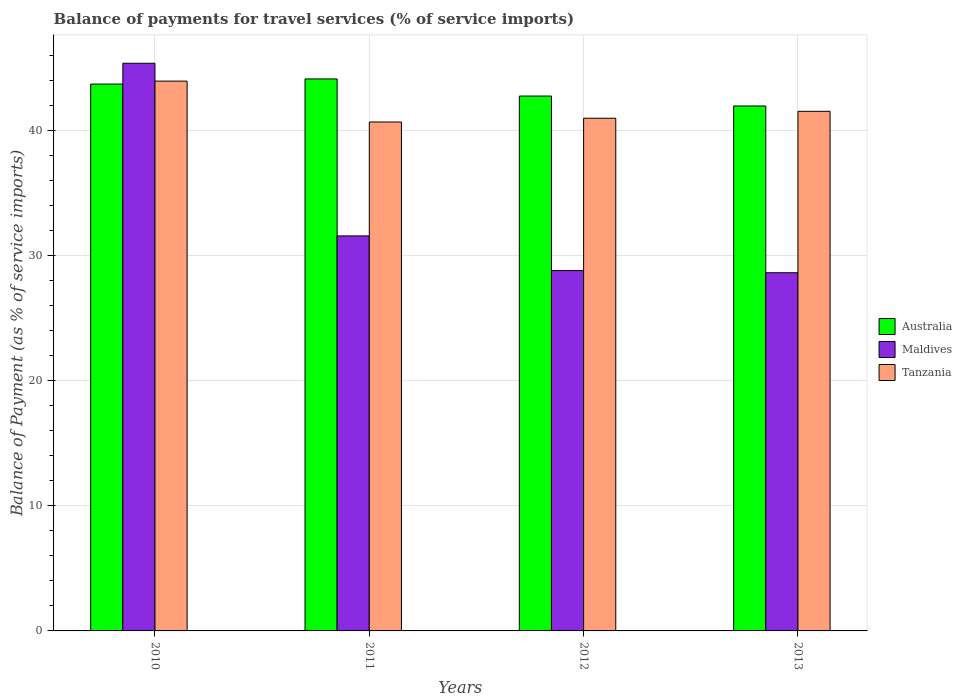How many groups of bars are there?
Keep it short and to the point. 4. Are the number of bars per tick equal to the number of legend labels?
Offer a terse response. Yes. Are the number of bars on each tick of the X-axis equal?
Offer a very short reply. Yes. How many bars are there on the 4th tick from the left?
Make the answer very short. 3. What is the label of the 2nd group of bars from the left?
Your response must be concise. 2011. In how many cases, is the number of bars for a given year not equal to the number of legend labels?
Offer a terse response. 0. What is the balance of payments for travel services in Maldives in 2012?
Keep it short and to the point. 28.81. Across all years, what is the maximum balance of payments for travel services in Maldives?
Provide a succinct answer. 45.39. Across all years, what is the minimum balance of payments for travel services in Tanzania?
Your response must be concise. 40.7. In which year was the balance of payments for travel services in Australia maximum?
Make the answer very short. 2011. What is the total balance of payments for travel services in Maldives in the graph?
Make the answer very short. 134.43. What is the difference between the balance of payments for travel services in Maldives in 2010 and that in 2013?
Your response must be concise. 16.75. What is the difference between the balance of payments for travel services in Tanzania in 2012 and the balance of payments for travel services in Australia in 2013?
Your answer should be compact. -0.98. What is the average balance of payments for travel services in Maldives per year?
Give a very brief answer. 33.61. In the year 2012, what is the difference between the balance of payments for travel services in Tanzania and balance of payments for travel services in Australia?
Provide a short and direct response. -1.77. What is the ratio of the balance of payments for travel services in Australia in 2012 to that in 2013?
Your answer should be compact. 1.02. Is the balance of payments for travel services in Maldives in 2011 less than that in 2012?
Your response must be concise. No. Is the difference between the balance of payments for travel services in Tanzania in 2011 and 2012 greater than the difference between the balance of payments for travel services in Australia in 2011 and 2012?
Provide a succinct answer. No. What is the difference between the highest and the second highest balance of payments for travel services in Maldives?
Provide a succinct answer. 13.81. What is the difference between the highest and the lowest balance of payments for travel services in Australia?
Offer a terse response. 2.16. In how many years, is the balance of payments for travel services in Tanzania greater than the average balance of payments for travel services in Tanzania taken over all years?
Provide a succinct answer. 1. What does the 2nd bar from the right in 2011 represents?
Your response must be concise. Maldives. Is it the case that in every year, the sum of the balance of payments for travel services in Australia and balance of payments for travel services in Maldives is greater than the balance of payments for travel services in Tanzania?
Your answer should be compact. Yes. Does the graph contain grids?
Offer a very short reply. Yes. What is the title of the graph?
Provide a short and direct response. Balance of payments for travel services (% of service imports). Does "Bhutan" appear as one of the legend labels in the graph?
Offer a very short reply. No. What is the label or title of the X-axis?
Give a very brief answer. Years. What is the label or title of the Y-axis?
Give a very brief answer. Balance of Payment (as % of service imports). What is the Balance of Payment (as % of service imports) in Australia in 2010?
Ensure brevity in your answer.  43.73. What is the Balance of Payment (as % of service imports) in Maldives in 2010?
Your response must be concise. 45.39. What is the Balance of Payment (as % of service imports) of Tanzania in 2010?
Offer a very short reply. 43.96. What is the Balance of Payment (as % of service imports) of Australia in 2011?
Your answer should be very brief. 44.14. What is the Balance of Payment (as % of service imports) of Maldives in 2011?
Keep it short and to the point. 31.59. What is the Balance of Payment (as % of service imports) in Tanzania in 2011?
Provide a succinct answer. 40.7. What is the Balance of Payment (as % of service imports) in Australia in 2012?
Make the answer very short. 42.77. What is the Balance of Payment (as % of service imports) of Maldives in 2012?
Offer a very short reply. 28.81. What is the Balance of Payment (as % of service imports) of Tanzania in 2012?
Offer a very short reply. 40.99. What is the Balance of Payment (as % of service imports) in Australia in 2013?
Your answer should be compact. 41.98. What is the Balance of Payment (as % of service imports) in Maldives in 2013?
Make the answer very short. 28.64. What is the Balance of Payment (as % of service imports) in Tanzania in 2013?
Offer a terse response. 41.55. Across all years, what is the maximum Balance of Payment (as % of service imports) in Australia?
Your answer should be compact. 44.14. Across all years, what is the maximum Balance of Payment (as % of service imports) of Maldives?
Offer a terse response. 45.39. Across all years, what is the maximum Balance of Payment (as % of service imports) of Tanzania?
Provide a succinct answer. 43.96. Across all years, what is the minimum Balance of Payment (as % of service imports) in Australia?
Provide a short and direct response. 41.98. Across all years, what is the minimum Balance of Payment (as % of service imports) of Maldives?
Give a very brief answer. 28.64. Across all years, what is the minimum Balance of Payment (as % of service imports) of Tanzania?
Provide a succinct answer. 40.7. What is the total Balance of Payment (as % of service imports) in Australia in the graph?
Offer a terse response. 172.61. What is the total Balance of Payment (as % of service imports) of Maldives in the graph?
Offer a very short reply. 134.43. What is the total Balance of Payment (as % of service imports) of Tanzania in the graph?
Provide a short and direct response. 167.2. What is the difference between the Balance of Payment (as % of service imports) in Australia in 2010 and that in 2011?
Make the answer very short. -0.41. What is the difference between the Balance of Payment (as % of service imports) of Maldives in 2010 and that in 2011?
Your answer should be very brief. 13.81. What is the difference between the Balance of Payment (as % of service imports) of Tanzania in 2010 and that in 2011?
Your answer should be very brief. 3.27. What is the difference between the Balance of Payment (as % of service imports) in Australia in 2010 and that in 2012?
Offer a very short reply. 0.96. What is the difference between the Balance of Payment (as % of service imports) of Maldives in 2010 and that in 2012?
Your answer should be very brief. 16.58. What is the difference between the Balance of Payment (as % of service imports) of Tanzania in 2010 and that in 2012?
Give a very brief answer. 2.97. What is the difference between the Balance of Payment (as % of service imports) in Australia in 2010 and that in 2013?
Offer a very short reply. 1.75. What is the difference between the Balance of Payment (as % of service imports) of Maldives in 2010 and that in 2013?
Your answer should be very brief. 16.75. What is the difference between the Balance of Payment (as % of service imports) in Tanzania in 2010 and that in 2013?
Offer a very short reply. 2.42. What is the difference between the Balance of Payment (as % of service imports) in Australia in 2011 and that in 2012?
Your answer should be very brief. 1.37. What is the difference between the Balance of Payment (as % of service imports) in Maldives in 2011 and that in 2012?
Make the answer very short. 2.77. What is the difference between the Balance of Payment (as % of service imports) of Tanzania in 2011 and that in 2012?
Offer a very short reply. -0.3. What is the difference between the Balance of Payment (as % of service imports) of Australia in 2011 and that in 2013?
Ensure brevity in your answer.  2.16. What is the difference between the Balance of Payment (as % of service imports) of Maldives in 2011 and that in 2013?
Ensure brevity in your answer.  2.94. What is the difference between the Balance of Payment (as % of service imports) in Tanzania in 2011 and that in 2013?
Provide a short and direct response. -0.85. What is the difference between the Balance of Payment (as % of service imports) in Australia in 2012 and that in 2013?
Your answer should be very brief. 0.79. What is the difference between the Balance of Payment (as % of service imports) of Maldives in 2012 and that in 2013?
Your answer should be compact. 0.17. What is the difference between the Balance of Payment (as % of service imports) of Tanzania in 2012 and that in 2013?
Provide a succinct answer. -0.55. What is the difference between the Balance of Payment (as % of service imports) in Australia in 2010 and the Balance of Payment (as % of service imports) in Maldives in 2011?
Provide a short and direct response. 12.14. What is the difference between the Balance of Payment (as % of service imports) of Australia in 2010 and the Balance of Payment (as % of service imports) of Tanzania in 2011?
Your answer should be very brief. 3.03. What is the difference between the Balance of Payment (as % of service imports) in Maldives in 2010 and the Balance of Payment (as % of service imports) in Tanzania in 2011?
Make the answer very short. 4.7. What is the difference between the Balance of Payment (as % of service imports) in Australia in 2010 and the Balance of Payment (as % of service imports) in Maldives in 2012?
Make the answer very short. 14.91. What is the difference between the Balance of Payment (as % of service imports) in Australia in 2010 and the Balance of Payment (as % of service imports) in Tanzania in 2012?
Your response must be concise. 2.73. What is the difference between the Balance of Payment (as % of service imports) in Maldives in 2010 and the Balance of Payment (as % of service imports) in Tanzania in 2012?
Provide a succinct answer. 4.4. What is the difference between the Balance of Payment (as % of service imports) in Australia in 2010 and the Balance of Payment (as % of service imports) in Maldives in 2013?
Your answer should be compact. 15.09. What is the difference between the Balance of Payment (as % of service imports) of Australia in 2010 and the Balance of Payment (as % of service imports) of Tanzania in 2013?
Provide a succinct answer. 2.18. What is the difference between the Balance of Payment (as % of service imports) in Maldives in 2010 and the Balance of Payment (as % of service imports) in Tanzania in 2013?
Your response must be concise. 3.84. What is the difference between the Balance of Payment (as % of service imports) of Australia in 2011 and the Balance of Payment (as % of service imports) of Maldives in 2012?
Keep it short and to the point. 15.33. What is the difference between the Balance of Payment (as % of service imports) of Australia in 2011 and the Balance of Payment (as % of service imports) of Tanzania in 2012?
Your answer should be very brief. 3.14. What is the difference between the Balance of Payment (as % of service imports) of Maldives in 2011 and the Balance of Payment (as % of service imports) of Tanzania in 2012?
Offer a terse response. -9.41. What is the difference between the Balance of Payment (as % of service imports) in Australia in 2011 and the Balance of Payment (as % of service imports) in Maldives in 2013?
Your response must be concise. 15.5. What is the difference between the Balance of Payment (as % of service imports) in Australia in 2011 and the Balance of Payment (as % of service imports) in Tanzania in 2013?
Provide a succinct answer. 2.59. What is the difference between the Balance of Payment (as % of service imports) of Maldives in 2011 and the Balance of Payment (as % of service imports) of Tanzania in 2013?
Keep it short and to the point. -9.96. What is the difference between the Balance of Payment (as % of service imports) of Australia in 2012 and the Balance of Payment (as % of service imports) of Maldives in 2013?
Ensure brevity in your answer.  14.13. What is the difference between the Balance of Payment (as % of service imports) in Australia in 2012 and the Balance of Payment (as % of service imports) in Tanzania in 2013?
Keep it short and to the point. 1.22. What is the difference between the Balance of Payment (as % of service imports) in Maldives in 2012 and the Balance of Payment (as % of service imports) in Tanzania in 2013?
Offer a terse response. -12.74. What is the average Balance of Payment (as % of service imports) in Australia per year?
Make the answer very short. 43.15. What is the average Balance of Payment (as % of service imports) in Maldives per year?
Make the answer very short. 33.61. What is the average Balance of Payment (as % of service imports) in Tanzania per year?
Offer a terse response. 41.8. In the year 2010, what is the difference between the Balance of Payment (as % of service imports) in Australia and Balance of Payment (as % of service imports) in Maldives?
Give a very brief answer. -1.67. In the year 2010, what is the difference between the Balance of Payment (as % of service imports) in Australia and Balance of Payment (as % of service imports) in Tanzania?
Provide a succinct answer. -0.24. In the year 2010, what is the difference between the Balance of Payment (as % of service imports) in Maldives and Balance of Payment (as % of service imports) in Tanzania?
Provide a succinct answer. 1.43. In the year 2011, what is the difference between the Balance of Payment (as % of service imports) of Australia and Balance of Payment (as % of service imports) of Maldives?
Your response must be concise. 12.55. In the year 2011, what is the difference between the Balance of Payment (as % of service imports) in Australia and Balance of Payment (as % of service imports) in Tanzania?
Your answer should be compact. 3.44. In the year 2011, what is the difference between the Balance of Payment (as % of service imports) in Maldives and Balance of Payment (as % of service imports) in Tanzania?
Give a very brief answer. -9.11. In the year 2012, what is the difference between the Balance of Payment (as % of service imports) in Australia and Balance of Payment (as % of service imports) in Maldives?
Your answer should be compact. 13.96. In the year 2012, what is the difference between the Balance of Payment (as % of service imports) in Australia and Balance of Payment (as % of service imports) in Tanzania?
Your answer should be compact. 1.77. In the year 2012, what is the difference between the Balance of Payment (as % of service imports) of Maldives and Balance of Payment (as % of service imports) of Tanzania?
Give a very brief answer. -12.18. In the year 2013, what is the difference between the Balance of Payment (as % of service imports) of Australia and Balance of Payment (as % of service imports) of Maldives?
Keep it short and to the point. 13.33. In the year 2013, what is the difference between the Balance of Payment (as % of service imports) of Australia and Balance of Payment (as % of service imports) of Tanzania?
Offer a very short reply. 0.43. In the year 2013, what is the difference between the Balance of Payment (as % of service imports) of Maldives and Balance of Payment (as % of service imports) of Tanzania?
Ensure brevity in your answer.  -12.91. What is the ratio of the Balance of Payment (as % of service imports) in Maldives in 2010 to that in 2011?
Ensure brevity in your answer.  1.44. What is the ratio of the Balance of Payment (as % of service imports) of Tanzania in 2010 to that in 2011?
Offer a terse response. 1.08. What is the ratio of the Balance of Payment (as % of service imports) of Australia in 2010 to that in 2012?
Provide a succinct answer. 1.02. What is the ratio of the Balance of Payment (as % of service imports) in Maldives in 2010 to that in 2012?
Keep it short and to the point. 1.58. What is the ratio of the Balance of Payment (as % of service imports) in Tanzania in 2010 to that in 2012?
Make the answer very short. 1.07. What is the ratio of the Balance of Payment (as % of service imports) in Australia in 2010 to that in 2013?
Make the answer very short. 1.04. What is the ratio of the Balance of Payment (as % of service imports) of Maldives in 2010 to that in 2013?
Provide a short and direct response. 1.58. What is the ratio of the Balance of Payment (as % of service imports) of Tanzania in 2010 to that in 2013?
Your answer should be very brief. 1.06. What is the ratio of the Balance of Payment (as % of service imports) of Australia in 2011 to that in 2012?
Give a very brief answer. 1.03. What is the ratio of the Balance of Payment (as % of service imports) in Maldives in 2011 to that in 2012?
Provide a short and direct response. 1.1. What is the ratio of the Balance of Payment (as % of service imports) of Tanzania in 2011 to that in 2012?
Ensure brevity in your answer.  0.99. What is the ratio of the Balance of Payment (as % of service imports) in Australia in 2011 to that in 2013?
Provide a succinct answer. 1.05. What is the ratio of the Balance of Payment (as % of service imports) in Maldives in 2011 to that in 2013?
Provide a short and direct response. 1.1. What is the ratio of the Balance of Payment (as % of service imports) of Tanzania in 2011 to that in 2013?
Your response must be concise. 0.98. What is the ratio of the Balance of Payment (as % of service imports) of Australia in 2012 to that in 2013?
Give a very brief answer. 1.02. What is the ratio of the Balance of Payment (as % of service imports) in Maldives in 2012 to that in 2013?
Provide a succinct answer. 1.01. What is the ratio of the Balance of Payment (as % of service imports) of Tanzania in 2012 to that in 2013?
Provide a succinct answer. 0.99. What is the difference between the highest and the second highest Balance of Payment (as % of service imports) in Australia?
Provide a short and direct response. 0.41. What is the difference between the highest and the second highest Balance of Payment (as % of service imports) of Maldives?
Offer a very short reply. 13.81. What is the difference between the highest and the second highest Balance of Payment (as % of service imports) of Tanzania?
Provide a succinct answer. 2.42. What is the difference between the highest and the lowest Balance of Payment (as % of service imports) in Australia?
Keep it short and to the point. 2.16. What is the difference between the highest and the lowest Balance of Payment (as % of service imports) of Maldives?
Provide a succinct answer. 16.75. What is the difference between the highest and the lowest Balance of Payment (as % of service imports) of Tanzania?
Your answer should be very brief. 3.27. 